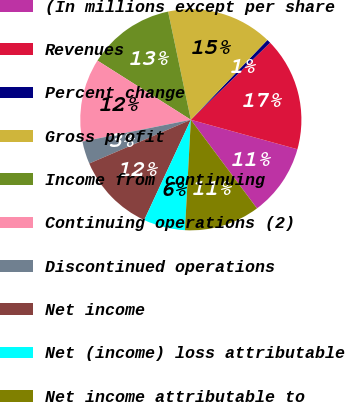Convert chart. <chart><loc_0><loc_0><loc_500><loc_500><pie_chart><fcel>(In millions except per share<fcel>Revenues<fcel>Percent change<fcel>Gross profit<fcel>Income from continuing<fcel>Continuing operations (2)<fcel>Discontinued operations<fcel>Net income<fcel>Net (income) loss attributable<fcel>Net income attributable to<nl><fcel>10.5%<fcel>16.57%<fcel>0.55%<fcel>15.47%<fcel>12.71%<fcel>12.15%<fcel>3.31%<fcel>11.6%<fcel>6.08%<fcel>11.05%<nl></chart> 